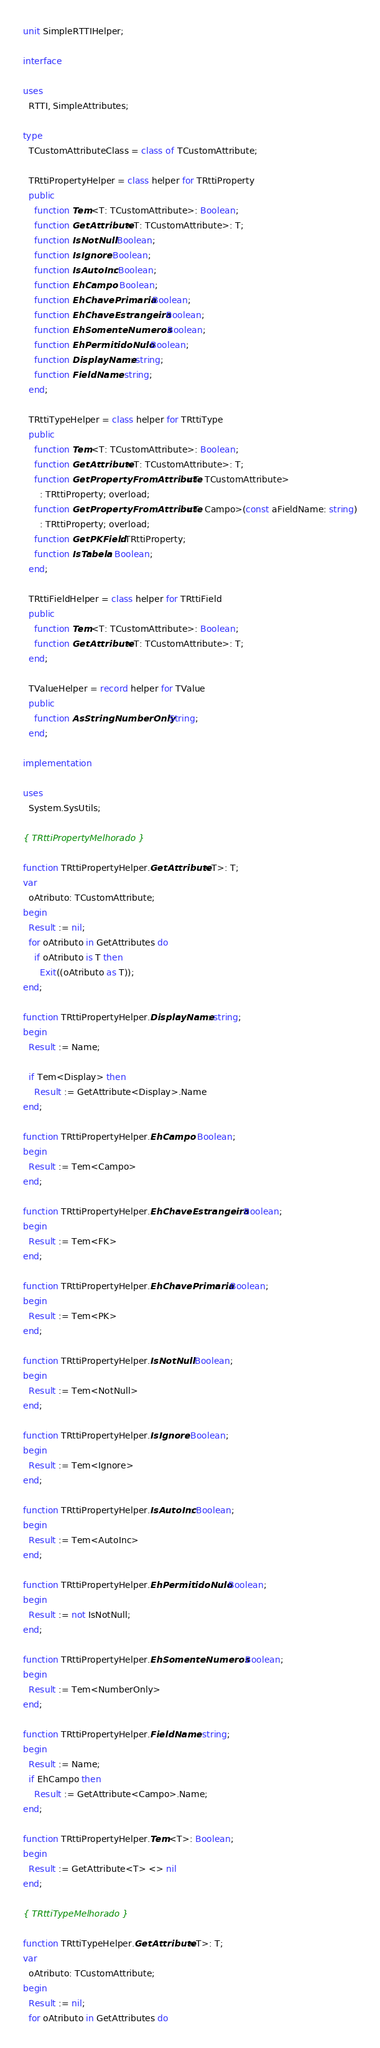<code> <loc_0><loc_0><loc_500><loc_500><_Pascal_>unit SimpleRTTIHelper;

interface

uses
  RTTI, SimpleAttributes;

type
  TCustomAttributeClass = class of TCustomAttribute;

  TRttiPropertyHelper = class helper for TRttiProperty
  public
    function Tem<T: TCustomAttribute>: Boolean;
    function GetAttribute<T: TCustomAttribute>: T;
    function IsNotNull: Boolean;
    function IsIgnore: Boolean;
    function IsAutoInc: Boolean;
    function EhCampo: Boolean;
    function EhChavePrimaria: Boolean;
    function EhChaveEstrangeira: Boolean;
    function EhSomenteNumeros: Boolean;
    function EhPermitidoNulo: Boolean;
    function DisplayName: string;
    function FieldName: string;
  end;

  TRttiTypeHelper = class helper for TRttiType
  public
    function Tem<T: TCustomAttribute>: Boolean;
    function GetAttribute<T: TCustomAttribute>: T;
    function GetPropertyFromAttribute<T: TCustomAttribute>
      : TRttiProperty; overload;
    function GetPropertyFromAttribute<T: Campo>(const aFieldName: string)
      : TRttiProperty; overload;
    function GetPKField: TRttiProperty;
    function IsTabela: Boolean;
  end;

  TRttiFieldHelper = class helper for TRttiField
  public
    function Tem<T: TCustomAttribute>: Boolean;
    function GetAttribute<T: TCustomAttribute>: T;
  end;

  TValueHelper = record helper for TValue
  public
    function AsStringNumberOnly: String;
  end;

implementation

uses
  System.SysUtils;

{ TRttiPropertyMelhorado }

function TRttiPropertyHelper.GetAttribute<T>: T;
var
  oAtributo: TCustomAttribute;
begin
  Result := nil;
  for oAtributo in GetAttributes do
    if oAtributo is T then
      Exit((oAtributo as T));
end;

function TRttiPropertyHelper.DisplayName: string;
begin
  Result := Name;

  if Tem<Display> then
    Result := GetAttribute<Display>.Name
end;

function TRttiPropertyHelper.EhCampo: Boolean;
begin
  Result := Tem<Campo>
end;

function TRttiPropertyHelper.EhChaveEstrangeira: Boolean;
begin
  Result := Tem<FK>
end;

function TRttiPropertyHelper.EhChavePrimaria: Boolean;
begin
  Result := Tem<PK>
end;

function TRttiPropertyHelper.IsNotNull: Boolean;
begin
  Result := Tem<NotNull>
end;

function TRttiPropertyHelper.IsIgnore: Boolean;
begin
  Result := Tem<Ignore>
end;

function TRttiPropertyHelper.IsAutoInc: Boolean;
begin
  Result := Tem<AutoInc>
end;

function TRttiPropertyHelper.EhPermitidoNulo: Boolean;
begin
  Result := not IsNotNull;
end;

function TRttiPropertyHelper.EhSomenteNumeros: Boolean;
begin
  Result := Tem<NumberOnly>
end;

function TRttiPropertyHelper.FieldName: string;
begin
  Result := Name;
  if EhCampo then
    Result := GetAttribute<Campo>.Name;
end;

function TRttiPropertyHelper.Tem<T>: Boolean;
begin
  Result := GetAttribute<T> <> nil
end;

{ TRttiTypeMelhorado }

function TRttiTypeHelper.GetAttribute<T>: T;
var
  oAtributo: TCustomAttribute;
begin
  Result := nil;
  for oAtributo in GetAttributes do</code> 